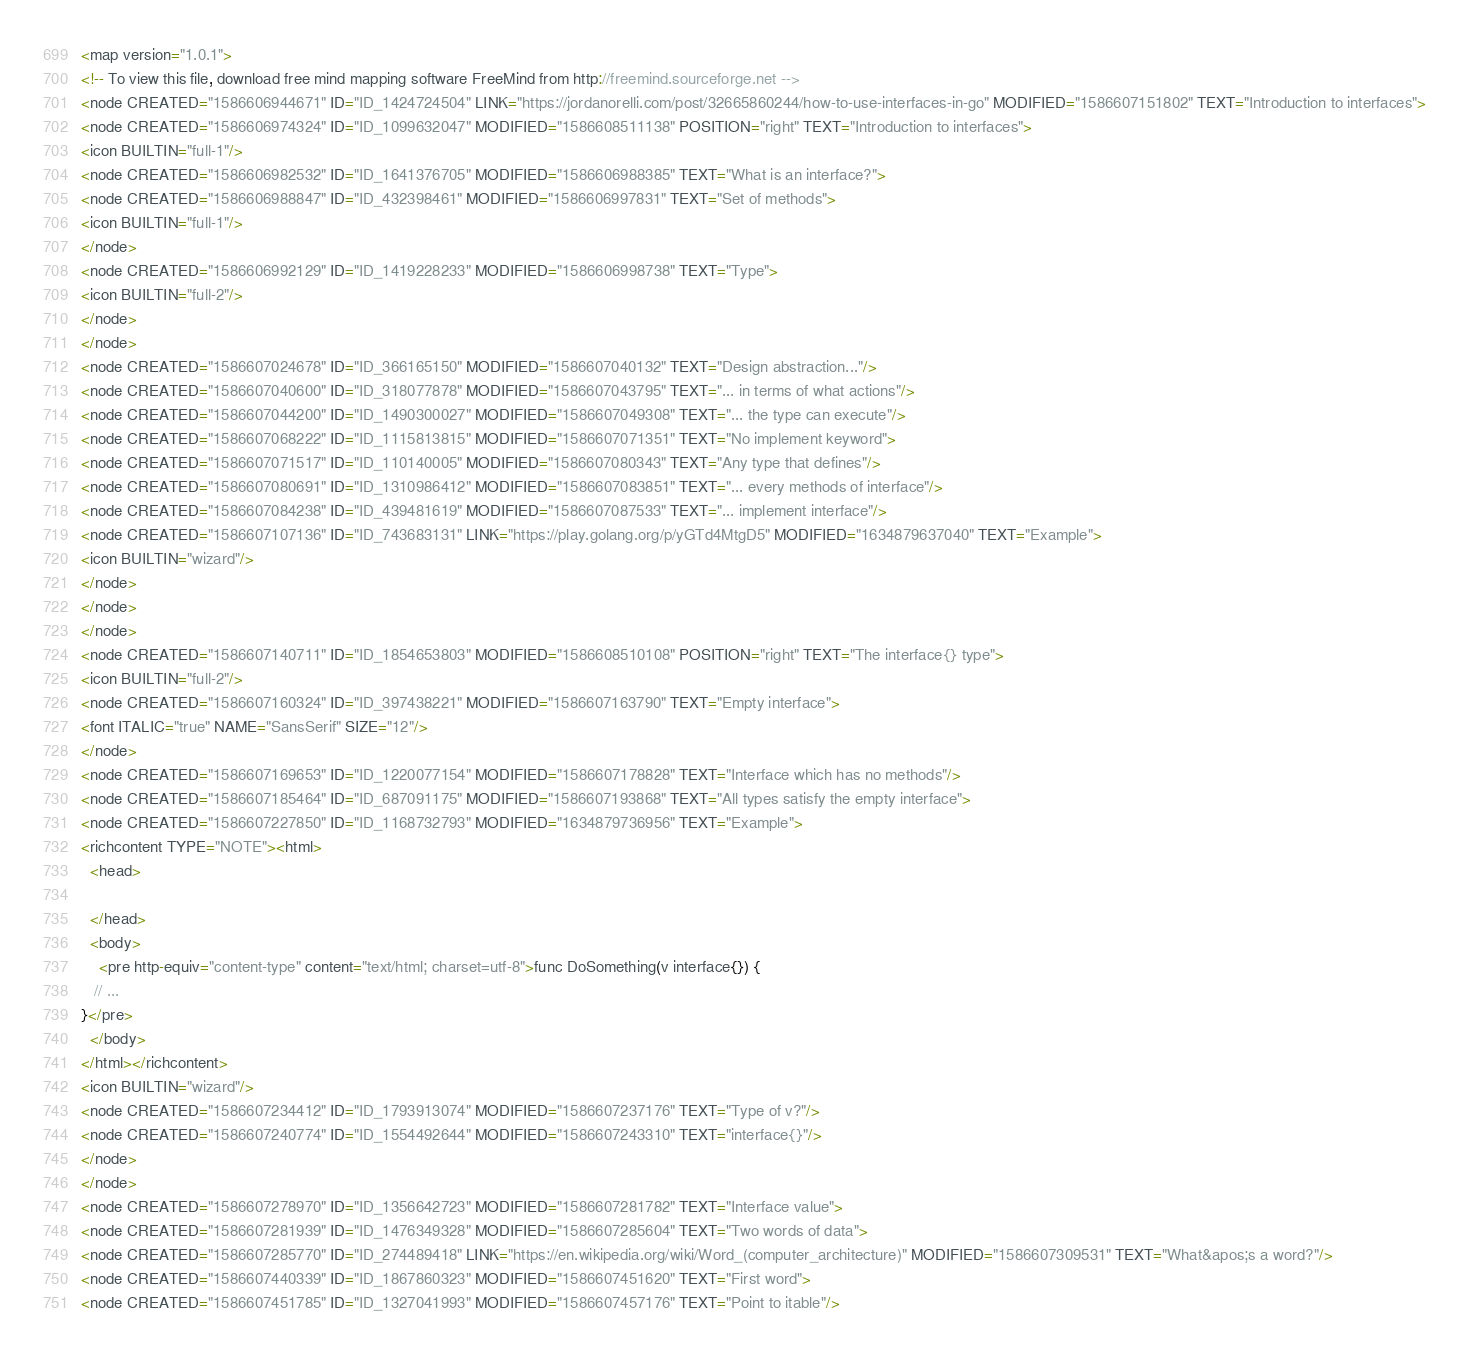Convert code to text. <code><loc_0><loc_0><loc_500><loc_500><_ObjectiveC_><map version="1.0.1">
<!-- To view this file, download free mind mapping software FreeMind from http://freemind.sourceforge.net -->
<node CREATED="1586606944671" ID="ID_1424724504" LINK="https://jordanorelli.com/post/32665860244/how-to-use-interfaces-in-go" MODIFIED="1586607151802" TEXT="Introduction to interfaces">
<node CREATED="1586606974324" ID="ID_1099632047" MODIFIED="1586608511138" POSITION="right" TEXT="Introduction to interfaces">
<icon BUILTIN="full-1"/>
<node CREATED="1586606982532" ID="ID_1641376705" MODIFIED="1586606988385" TEXT="What is an interface?">
<node CREATED="1586606988847" ID="ID_432398461" MODIFIED="1586606997831" TEXT="Set of methods">
<icon BUILTIN="full-1"/>
</node>
<node CREATED="1586606992129" ID="ID_1419228233" MODIFIED="1586606998738" TEXT="Type">
<icon BUILTIN="full-2"/>
</node>
</node>
<node CREATED="1586607024678" ID="ID_366165150" MODIFIED="1586607040132" TEXT="Design abstraction..."/>
<node CREATED="1586607040600" ID="ID_318077878" MODIFIED="1586607043795" TEXT="... in terms of what actions"/>
<node CREATED="1586607044200" ID="ID_1490300027" MODIFIED="1586607049308" TEXT="... the type can execute"/>
<node CREATED="1586607068222" ID="ID_1115813815" MODIFIED="1586607071351" TEXT="No implement keyword">
<node CREATED="1586607071517" ID="ID_110140005" MODIFIED="1586607080343" TEXT="Any type that defines"/>
<node CREATED="1586607080691" ID="ID_1310986412" MODIFIED="1586607083851" TEXT="... every methods of interface"/>
<node CREATED="1586607084238" ID="ID_439481619" MODIFIED="1586607087533" TEXT="... implement interface"/>
<node CREATED="1586607107136" ID="ID_743683131" LINK="https://play.golang.org/p/yGTd4MtgD5" MODIFIED="1634879637040" TEXT="Example">
<icon BUILTIN="wizard"/>
</node>
</node>
</node>
<node CREATED="1586607140711" ID="ID_1854653803" MODIFIED="1586608510108" POSITION="right" TEXT="The interface{} type">
<icon BUILTIN="full-2"/>
<node CREATED="1586607160324" ID="ID_397438221" MODIFIED="1586607163790" TEXT="Empty interface">
<font ITALIC="true" NAME="SansSerif" SIZE="12"/>
</node>
<node CREATED="1586607169653" ID="ID_1220077154" MODIFIED="1586607178828" TEXT="Interface which has no methods"/>
<node CREATED="1586607185464" ID="ID_687091175" MODIFIED="1586607193868" TEXT="All types satisfy the empty interface">
<node CREATED="1586607227850" ID="ID_1168732793" MODIFIED="1634879736956" TEXT="Example">
<richcontent TYPE="NOTE"><html>
  <head>
    
  </head>
  <body>
    <pre http-equiv="content-type" content="text/html; charset=utf-8">func DoSomething(v interface{}) {
   // ...
}</pre>
  </body>
</html></richcontent>
<icon BUILTIN="wizard"/>
<node CREATED="1586607234412" ID="ID_1793913074" MODIFIED="1586607237176" TEXT="Type of v?"/>
<node CREATED="1586607240774" ID="ID_1554492644" MODIFIED="1586607243310" TEXT="interface{}"/>
</node>
</node>
<node CREATED="1586607278970" ID="ID_1356642723" MODIFIED="1586607281782" TEXT="Interface value">
<node CREATED="1586607281939" ID="ID_1476349328" MODIFIED="1586607285604" TEXT="Two words of data">
<node CREATED="1586607285770" ID="ID_274489418" LINK="https://en.wikipedia.org/wiki/Word_(computer_architecture)" MODIFIED="1586607309531" TEXT="What&apos;s a word?"/>
<node CREATED="1586607440339" ID="ID_1867860323" MODIFIED="1586607451620" TEXT="First word">
<node CREATED="1586607451785" ID="ID_1327041993" MODIFIED="1586607457176" TEXT="Point to itable"/></code> 